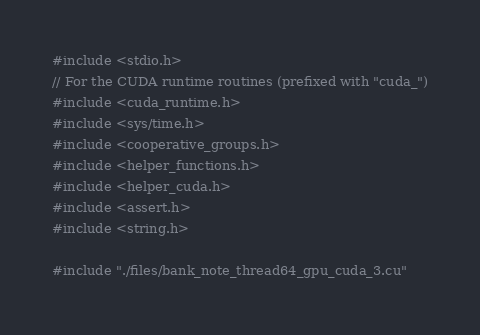<code> <loc_0><loc_0><loc_500><loc_500><_Cuda_>#include <stdio.h>
// For the CUDA runtime routines (prefixed with "cuda_")
#include <cuda_runtime.h>
#include <sys/time.h>
#include <cooperative_groups.h>
#include <helper_functions.h>
#include <helper_cuda.h>
#include <assert.h>
#include <string.h>

#include "./files/bank_note_thread64_gpu_cuda_3.cu"</code> 